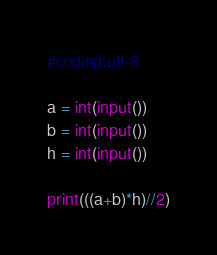Convert code to text. <code><loc_0><loc_0><loc_500><loc_500><_Python_>#coding:utf-8

a = int(input())
b = int(input())
h = int(input())

print(((a+b)*h)//2)
</code> 